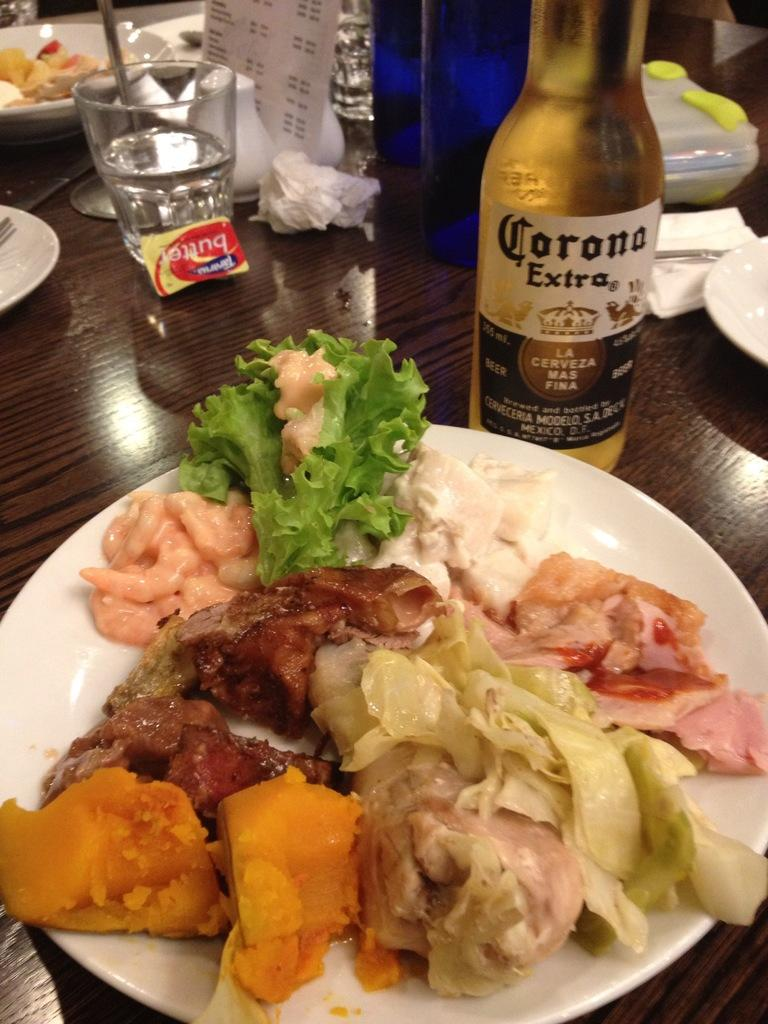What is on the plate that is visible on the table in the image? There is a plate full of food on the table. What type of beverage is in the bottle on the table? There is a wine bottle on the table. What type of drink is in the glass on the table? There is a glass of water on the table. What type of items are on the table that are not related to food or drink? There are papers on the table. Can you describe any other objects on the table? There are other objects on the table, but their specific details are not mentioned in the provided facts. What type of ocean can be seen in the background of the image? There is no ocean visible in the image; it is focused on the table and its contents. What flavor of notebook is on the table in the image? There is no notebook present in the image. 